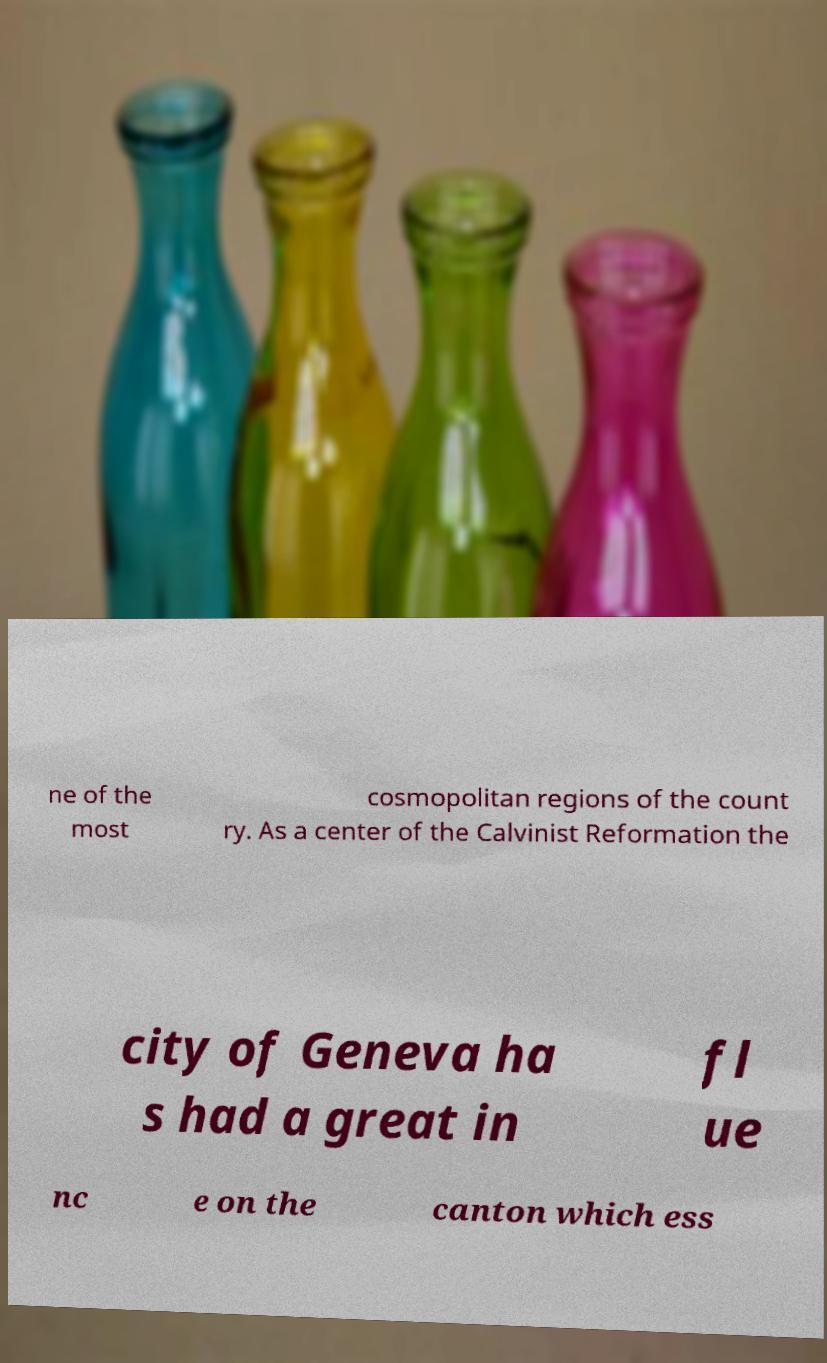There's text embedded in this image that I need extracted. Can you transcribe it verbatim? ne of the most cosmopolitan regions of the count ry. As a center of the Calvinist Reformation the city of Geneva ha s had a great in fl ue nc e on the canton which ess 